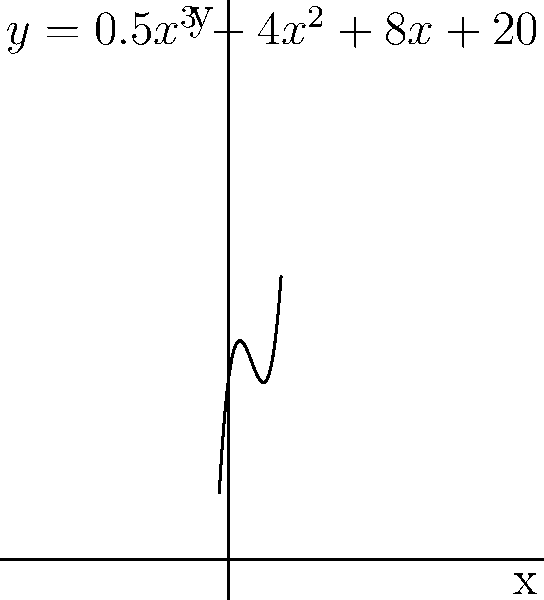As a comic book store employee, you're analyzing the sales trend of a popular superhero series using the polynomial function $y = 0.5x^3 - 4x^2 + 8x + 20$, where $x$ represents months since the series launch and $y$ represents monthly sales in hundreds. At which month does the series hit its lowest sales before rebounding? To find the month with the lowest sales, we need to determine the local minimum of the function. This occurs where the derivative of the function equals zero and the second derivative is positive.

Step 1: Find the derivative of the function.
$f'(x) = 1.5x^2 - 8x + 8$

Step 2: Set the derivative equal to zero and solve for x.
$1.5x^2 - 8x + 8 = 0$

Step 3: Use the quadratic formula to solve this equation.
$x = \frac{8 \pm \sqrt{64 - 48}}{3} = \frac{8 \pm 4}{3}$

This gives us two solutions: $x = 4$ or $x = \frac{4}{3}$

Step 4: Check the second derivative to confirm which solution is the minimum.
$f''(x) = 3x - 8$

At $x = 4$: $f''(4) = 12 - 8 = 4$ (positive, indicating a minimum)
At $x = \frac{4}{3}$: $f''(\frac{4}{3}) = 4 - 8 = -4$ (negative, indicating a maximum)

Therefore, the local minimum occurs at $x = 4$.

Step 5: Interpret the result.
Since $x$ represents months, the series hits its lowest sales at month 4 before rebounding.
Answer: 4 months 